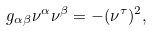Convert formula to latex. <formula><loc_0><loc_0><loc_500><loc_500>g _ { \alpha \beta } \nu ^ { \alpha } \nu ^ { \beta } = - ( \nu ^ { \tau } ) ^ { 2 } ,</formula> 